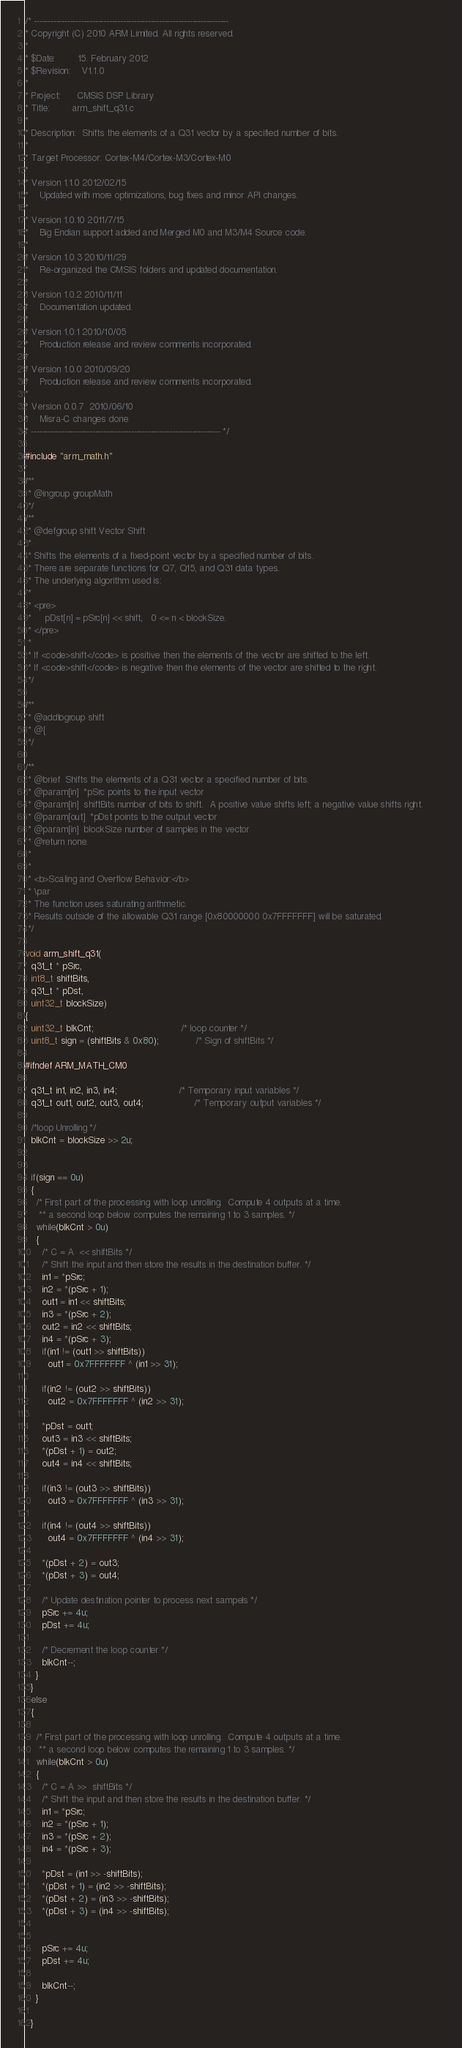Convert code to text. <code><loc_0><loc_0><loc_500><loc_500><_C_>/* ----------------------------------------------------------------------    
* Copyright (C) 2010 ARM Limited. All rights reserved.    
*    
* $Date:        15. February 2012  
* $Revision: 	V1.1.0  
*    
* Project: 	    CMSIS DSP Library    
* Title:		arm_shift_q31.c    
*    
* Description:	Shifts the elements of a Q31 vector by a specified number of bits.    
*    
* Target Processor: Cortex-M4/Cortex-M3/Cortex-M0
*  
* Version 1.1.0 2012/02/15 
*    Updated with more optimizations, bug fixes and minor API changes.  
*   
* Version 1.0.10 2011/7/15  
*    Big Endian support added and Merged M0 and M3/M4 Source code.   
*    
* Version 1.0.3 2010/11/29   
*    Re-organized the CMSIS folders and updated documentation.    
*     
* Version 1.0.2 2010/11/11    
*    Documentation updated.     
*    
* Version 1.0.1 2010/10/05     
*    Production release and review comments incorporated.    
*    
* Version 1.0.0 2010/09/20     
*    Production release and review comments incorporated.    
*    
* Version 0.0.7  2010/06/10     
*    Misra-C changes done    
* -------------------------------------------------------------------- */

#include "arm_math.h"

/**        
 * @ingroup groupMath        
 */
/**        
 * @defgroup shift Vector Shift        
 *        
 * Shifts the elements of a fixed-point vector by a specified number of bits.        
 * There are separate functions for Q7, Q15, and Q31 data types.        
 * The underlying algorithm used is:        
 *        
 * <pre>        
 *     pDst[n] = pSrc[n] << shift,   0 <= n < blockSize.        
 * </pre>        
 *        
 * If <code>shift</code> is positive then the elements of the vector are shifted to the left.        
 * If <code>shift</code> is negative then the elements of the vector are shifted to the right.        
 */

/**        
 * @addtogroup shift        
 * @{        
 */

/**        
 * @brief  Shifts the elements of a Q31 vector a specified number of bits.        
 * @param[in]  *pSrc points to the input vector        
 * @param[in]  shiftBits number of bits to shift.  A positive value shifts left; a negative value shifts right.        
 * @param[out]  *pDst points to the output vector        
 * @param[in]  blockSize number of samples in the vector        
 * @return none.        
 *        
 *        
 * <b>Scaling and Overflow Behavior:</b>        
 * \par        
 * The function uses saturating arithmetic.        
 * Results outside of the allowable Q31 range [0x80000000 0x7FFFFFFF] will be saturated.        
 */

void arm_shift_q31(
  q31_t * pSrc,
  int8_t shiftBits,
  q31_t * pDst,
  uint32_t blockSize)
{
  uint32_t blkCnt;                               /* loop counter */
  uint8_t sign = (shiftBits & 0x80);             /* Sign of shiftBits */

#ifndef ARM_MATH_CM0

  q31_t in1, in2, in3, in4;                      /* Temporary input variables */
  q31_t out1, out2, out3, out4;                  /* Temporary output variables */

  /*loop Unrolling */
  blkCnt = blockSize >> 2u;


  if(sign == 0u)
  {
    /* First part of the processing with loop unrolling.  Compute 4 outputs at a time.    
     ** a second loop below computes the remaining 1 to 3 samples. */
    while(blkCnt > 0u)
    {
      /* C = A  << shiftBits */
      /* Shift the input and then store the results in the destination buffer. */
      in1 = *pSrc;
      in2 = *(pSrc + 1);
      out1 = in1 << shiftBits;
      in3 = *(pSrc + 2);
      out2 = in2 << shiftBits;
      in4 = *(pSrc + 3);
      if(in1 != (out1 >> shiftBits))
        out1 = 0x7FFFFFFF ^ (in1 >> 31);

      if(in2 != (out2 >> shiftBits))
        out2 = 0x7FFFFFFF ^ (in2 >> 31);

      *pDst = out1;
      out3 = in3 << shiftBits;
      *(pDst + 1) = out2;
      out4 = in4 << shiftBits;

      if(in3 != (out3 >> shiftBits))
        out3 = 0x7FFFFFFF ^ (in3 >> 31);

      if(in4 != (out4 >> shiftBits))
        out4 = 0x7FFFFFFF ^ (in4 >> 31);

      *(pDst + 2) = out3;
      *(pDst + 3) = out4;

      /* Update destination pointer to process next sampels */
      pSrc += 4u;
      pDst += 4u;

      /* Decrement the loop counter */
      blkCnt--;
    }
  }
  else
  {

    /* First part of the processing with loop unrolling.  Compute 4 outputs at a time.    
     ** a second loop below computes the remaining 1 to 3 samples. */
    while(blkCnt > 0u)
    {
      /* C = A >>  shiftBits */
      /* Shift the input and then store the results in the destination buffer. */
      in1 = *pSrc;
      in2 = *(pSrc + 1);
      in3 = *(pSrc + 2);
      in4 = *(pSrc + 3);

      *pDst = (in1 >> -shiftBits);
      *(pDst + 1) = (in2 >> -shiftBits);
      *(pDst + 2) = (in3 >> -shiftBits);
      *(pDst + 3) = (in4 >> -shiftBits);


      pSrc += 4u;
      pDst += 4u;

      blkCnt--;
    }

  }
</code> 